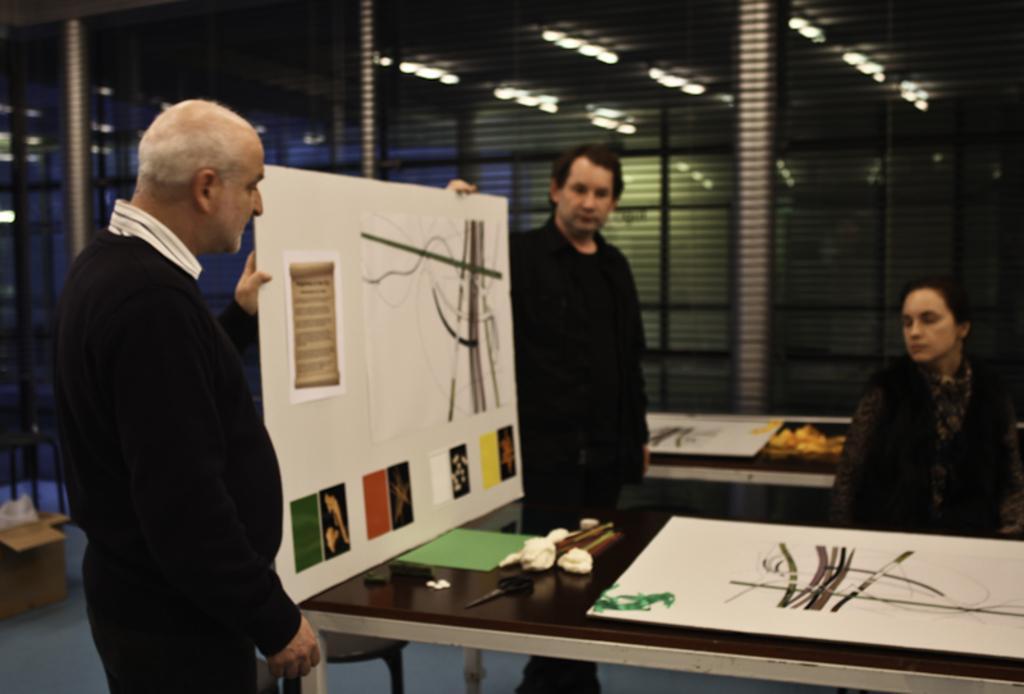Please provide a concise description of this image. In this picture there is a woman sitting on a chair. There are two men who are holding a board and are standing. There is a white sheet, scissor, green paper, cotton on the table. There are some lights at the background. There is a chair and box. 